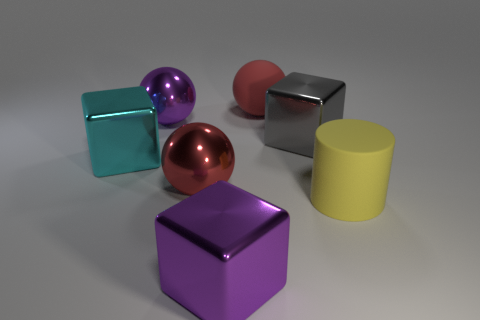Add 1 big cyan metallic cylinders. How many objects exist? 8 Subtract 2 balls. How many balls are left? 1 Subtract all brown cylinders. Subtract all cyan balls. How many cylinders are left? 1 Subtract all red spheres. How many yellow blocks are left? 0 Subtract all small shiny spheres. Subtract all cylinders. How many objects are left? 6 Add 7 large red rubber spheres. How many large red rubber spheres are left? 8 Add 3 big green cylinders. How many big green cylinders exist? 3 Subtract all purple spheres. How many spheres are left? 2 Subtract all large metal spheres. How many spheres are left? 1 Subtract 0 brown blocks. How many objects are left? 7 